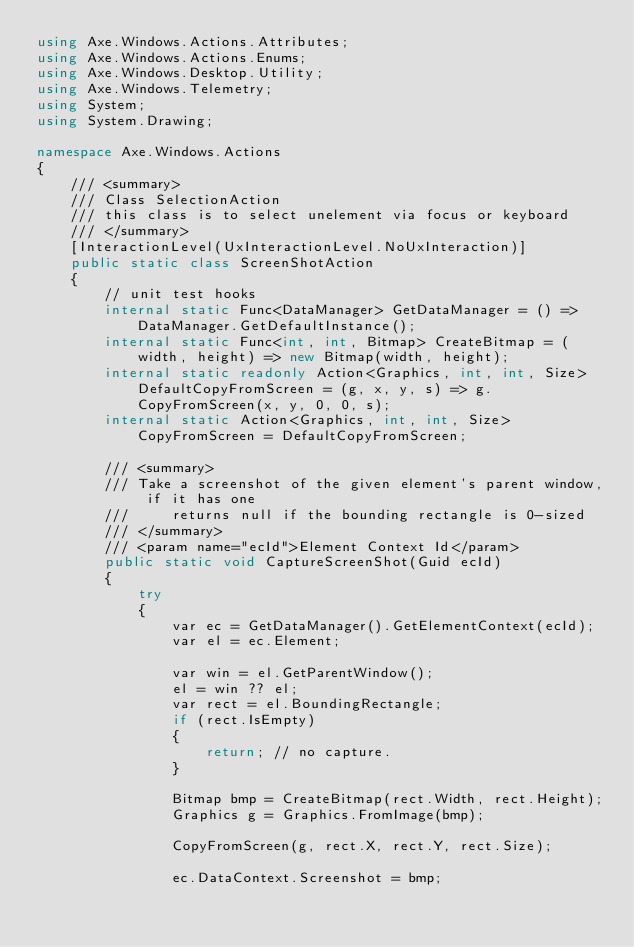<code> <loc_0><loc_0><loc_500><loc_500><_C#_>using Axe.Windows.Actions.Attributes;
using Axe.Windows.Actions.Enums;
using Axe.Windows.Desktop.Utility;
using Axe.Windows.Telemetry;
using System;
using System.Drawing;

namespace Axe.Windows.Actions
{
    /// <summary>
    /// Class SelectionAction
    /// this class is to select unelement via focus or keyboard
    /// </summary>
    [InteractionLevel(UxInteractionLevel.NoUxInteraction)]
    public static class ScreenShotAction
    {
        // unit test hooks
        internal static Func<DataManager> GetDataManager = () => DataManager.GetDefaultInstance();
        internal static Func<int, int, Bitmap> CreateBitmap = (width, height) => new Bitmap(width, height);
        internal static readonly Action<Graphics, int, int, Size> DefaultCopyFromScreen = (g, x, y, s) => g.CopyFromScreen(x, y, 0, 0, s);
        internal static Action<Graphics, int, int, Size> CopyFromScreen = DefaultCopyFromScreen;

        /// <summary>
        /// Take a screenshot of the given element's parent window, if it has one
        ///     returns null if the bounding rectangle is 0-sized
        /// </summary>
        /// <param name="ecId">Element Context Id</param>
        public static void CaptureScreenShot(Guid ecId)
        {
            try
            {
                var ec = GetDataManager().GetElementContext(ecId);
                var el = ec.Element;

                var win = el.GetParentWindow();
                el = win ?? el;
                var rect = el.BoundingRectangle;
                if (rect.IsEmpty)
                {
                    return; // no capture.
                }

                Bitmap bmp = CreateBitmap(rect.Width, rect.Height);
                Graphics g = Graphics.FromImage(bmp);

                CopyFromScreen(g, rect.X, rect.Y, rect.Size);

                ec.DataContext.Screenshot = bmp;</code> 